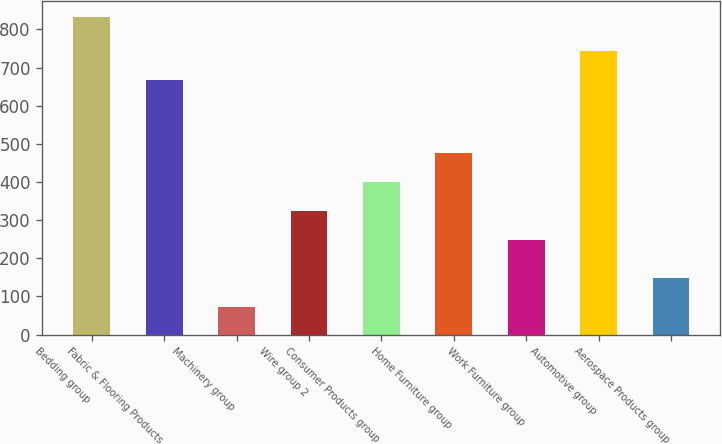<chart> <loc_0><loc_0><loc_500><loc_500><bar_chart><fcel>Bedding group<fcel>Fabric & Flooring Products<fcel>Machinery group<fcel>Wire group 2<fcel>Consumer Products group<fcel>Home Furniture group<fcel>Work Furniture group<fcel>Automotive group<fcel>Aerospace Products group<nl><fcel>831.8<fcel>666.8<fcel>72.8<fcel>324.7<fcel>400.6<fcel>476.5<fcel>248.8<fcel>742.7<fcel>148.7<nl></chart> 